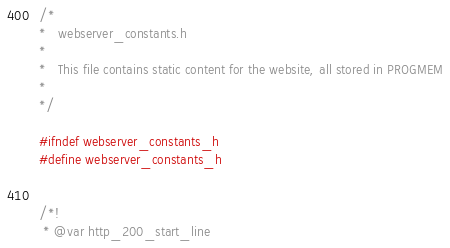Convert code to text. <code><loc_0><loc_0><loc_500><loc_500><_C_>/*
*   webserver_constants.h
*   
*   This file contains static content for the website, all stored in PROGMEM
*   
*/

#ifndef webserver_constants_h
#define webserver_constants_h


/*!
 * @var http_200_start_line</code> 